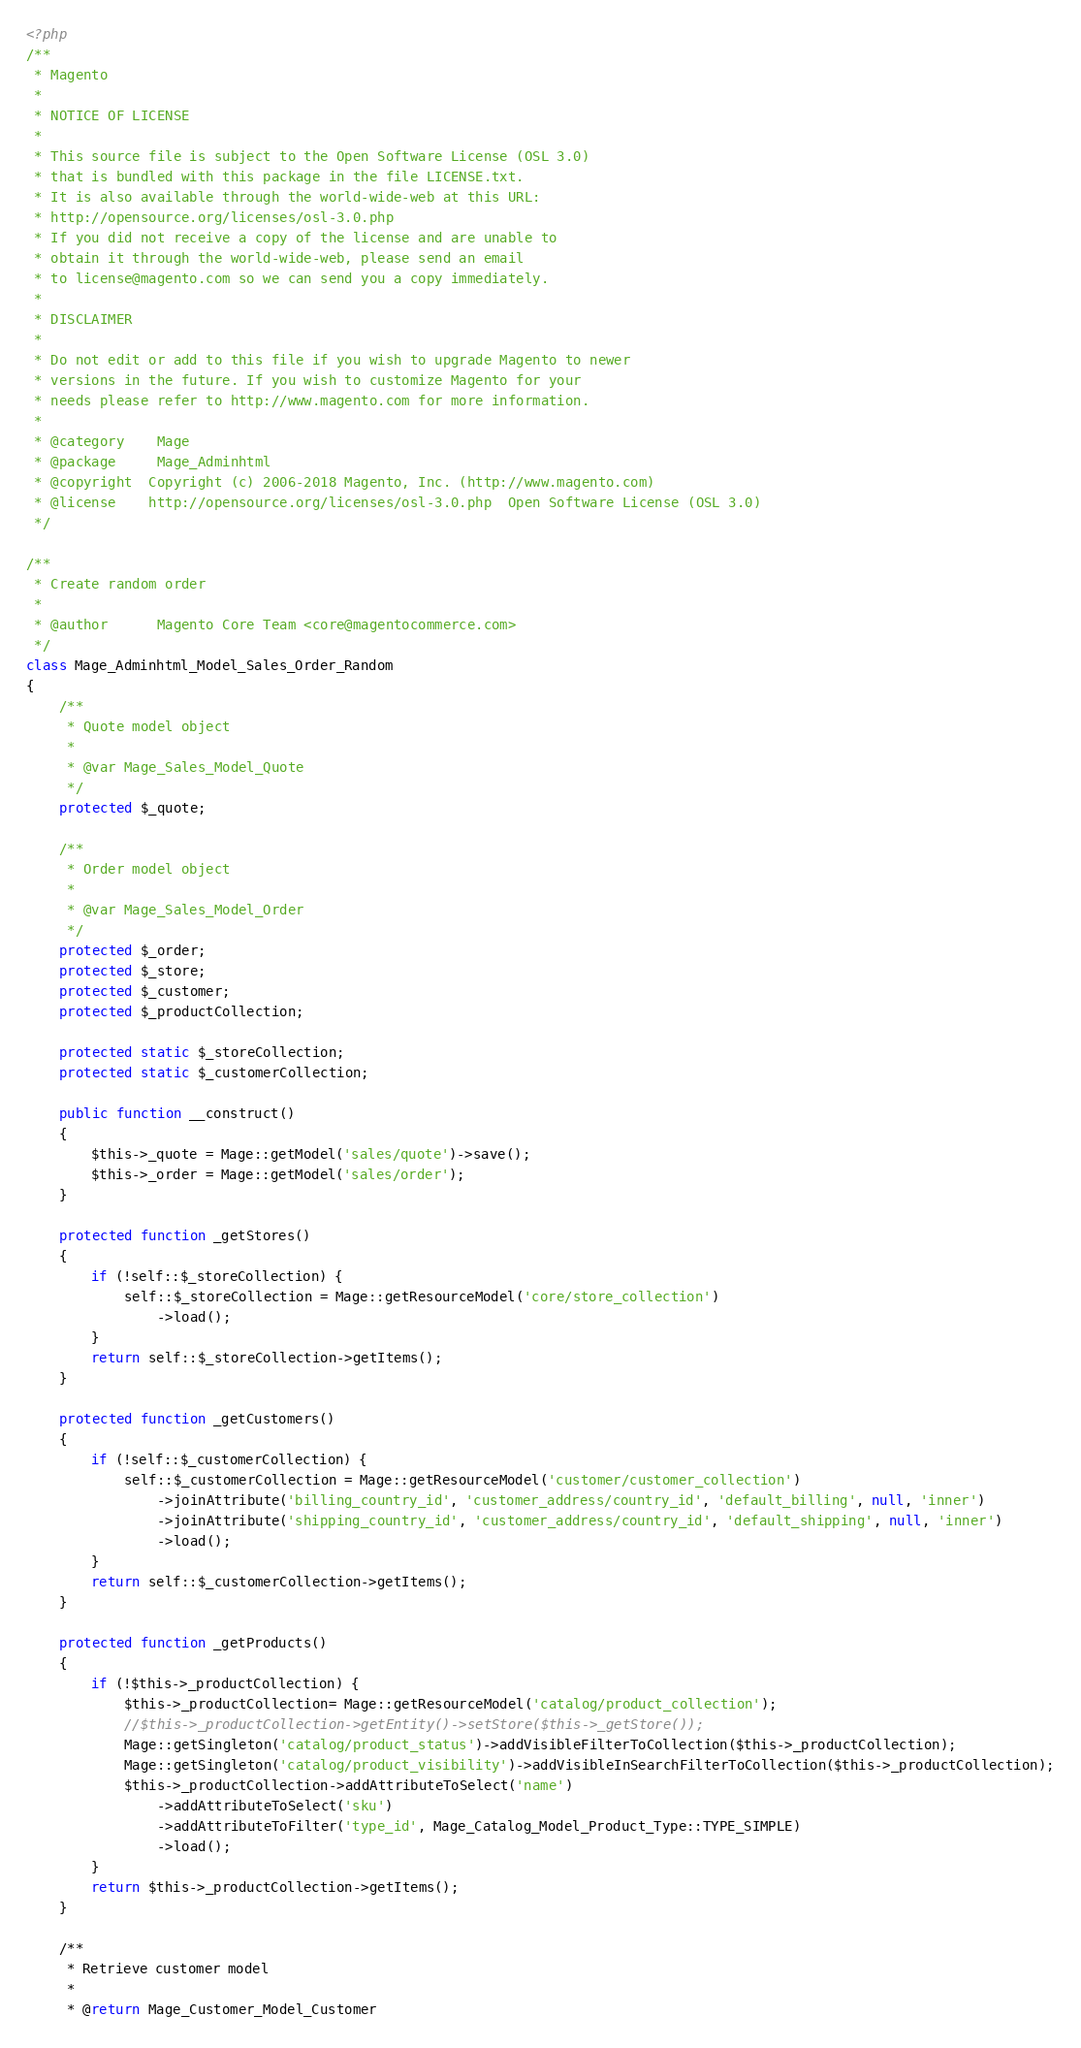<code> <loc_0><loc_0><loc_500><loc_500><_PHP_><?php
/**
 * Magento
 *
 * NOTICE OF LICENSE
 *
 * This source file is subject to the Open Software License (OSL 3.0)
 * that is bundled with this package in the file LICENSE.txt.
 * It is also available through the world-wide-web at this URL:
 * http://opensource.org/licenses/osl-3.0.php
 * If you did not receive a copy of the license and are unable to
 * obtain it through the world-wide-web, please send an email
 * to license@magento.com so we can send you a copy immediately.
 *
 * DISCLAIMER
 *
 * Do not edit or add to this file if you wish to upgrade Magento to newer
 * versions in the future. If you wish to customize Magento for your
 * needs please refer to http://www.magento.com for more information.
 *
 * @category    Mage
 * @package     Mage_Adminhtml
 * @copyright  Copyright (c) 2006-2018 Magento, Inc. (http://www.magento.com)
 * @license    http://opensource.org/licenses/osl-3.0.php  Open Software License (OSL 3.0)
 */

/**
 * Create random order
 *
 * @author      Magento Core Team <core@magentocommerce.com>
 */
class Mage_Adminhtml_Model_Sales_Order_Random
{
    /**
     * Quote model object
     *
     * @var Mage_Sales_Model_Quote
     */
    protected $_quote;

    /**
     * Order model object
     *
     * @var Mage_Sales_Model_Order
     */
    protected $_order;
    protected $_store;
    protected $_customer;
    protected $_productCollection;

    protected static $_storeCollection;
    protected static $_customerCollection;

    public function __construct()
    {
        $this->_quote = Mage::getModel('sales/quote')->save();
        $this->_order = Mage::getModel('sales/order');
    }

    protected function _getStores()
    {
        if (!self::$_storeCollection) {
            self::$_storeCollection = Mage::getResourceModel('core/store_collection')
                ->load();
        }
        return self::$_storeCollection->getItems();
    }

    protected function _getCustomers()
    {
        if (!self::$_customerCollection) {
            self::$_customerCollection = Mage::getResourceModel('customer/customer_collection')
                ->joinAttribute('billing_country_id', 'customer_address/country_id', 'default_billing', null, 'inner')
                ->joinAttribute('shipping_country_id', 'customer_address/country_id', 'default_shipping', null, 'inner')
                ->load();
        }
        return self::$_customerCollection->getItems();
    }

    protected function _getProducts()
    {
        if (!$this->_productCollection) {
            $this->_productCollection= Mage::getResourceModel('catalog/product_collection');
            //$this->_productCollection->getEntity()->setStore($this->_getStore());
            Mage::getSingleton('catalog/product_status')->addVisibleFilterToCollection($this->_productCollection);
            Mage::getSingleton('catalog/product_visibility')->addVisibleInSearchFilterToCollection($this->_productCollection);
            $this->_productCollection->addAttributeToSelect('name')
                ->addAttributeToSelect('sku')
                ->addAttributeToFilter('type_id', Mage_Catalog_Model_Product_Type::TYPE_SIMPLE)
                ->load();
        }
        return $this->_productCollection->getItems();
    }

    /**
     * Retrieve customer model
     *
     * @return Mage_Customer_Model_Customer</code> 